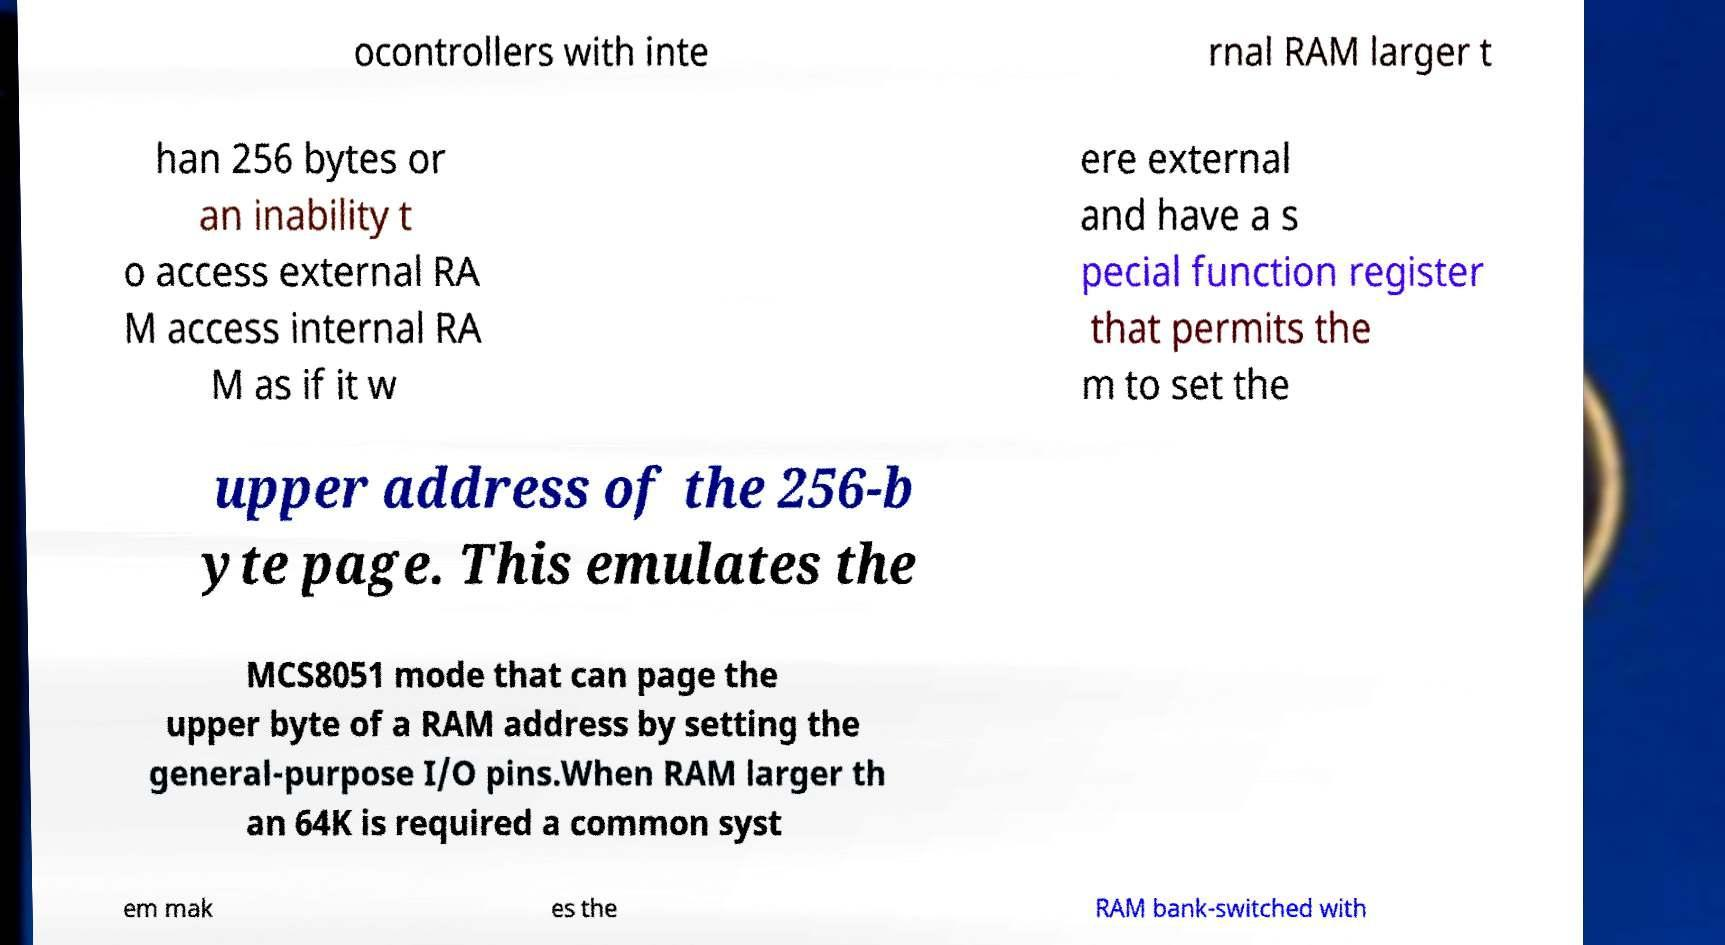Please identify and transcribe the text found in this image. ocontrollers with inte rnal RAM larger t han 256 bytes or an inability t o access external RA M access internal RA M as if it w ere external and have a s pecial function register that permits the m to set the upper address of the 256-b yte page. This emulates the MCS8051 mode that can page the upper byte of a RAM address by setting the general-purpose I/O pins.When RAM larger th an 64K is required a common syst em mak es the RAM bank-switched with 